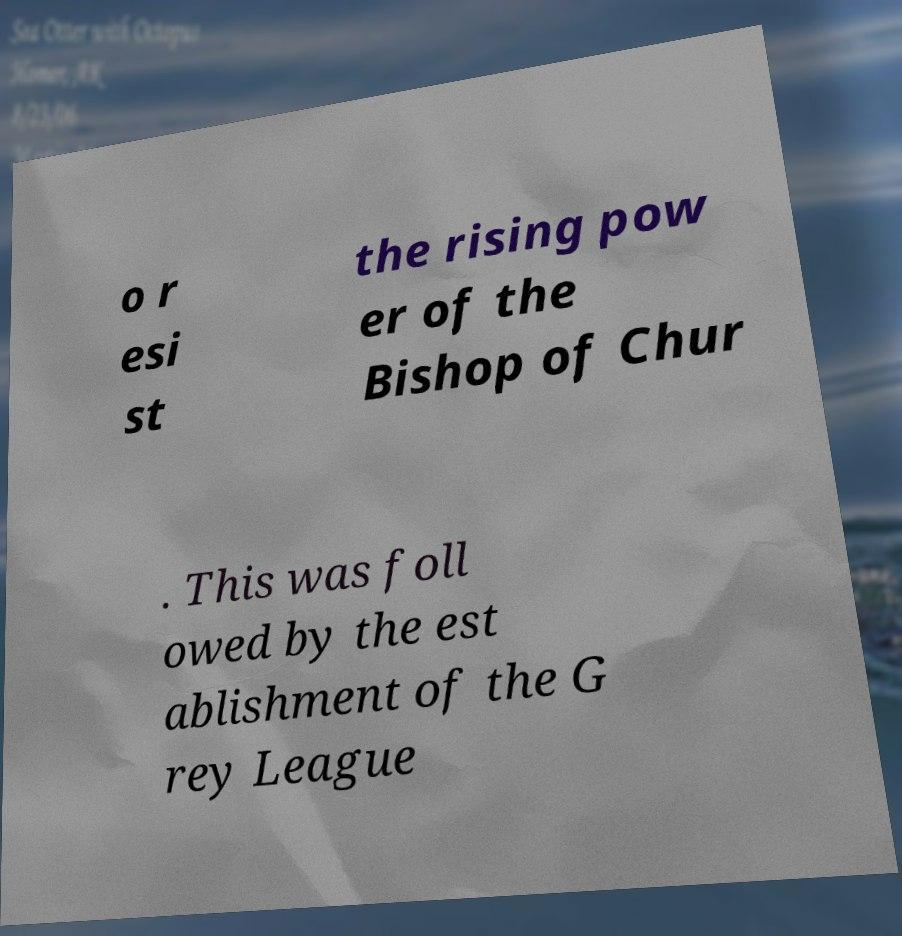Can you read and provide the text displayed in the image?This photo seems to have some interesting text. Can you extract and type it out for me? o r esi st the rising pow er of the Bishop of Chur . This was foll owed by the est ablishment of the G rey League 